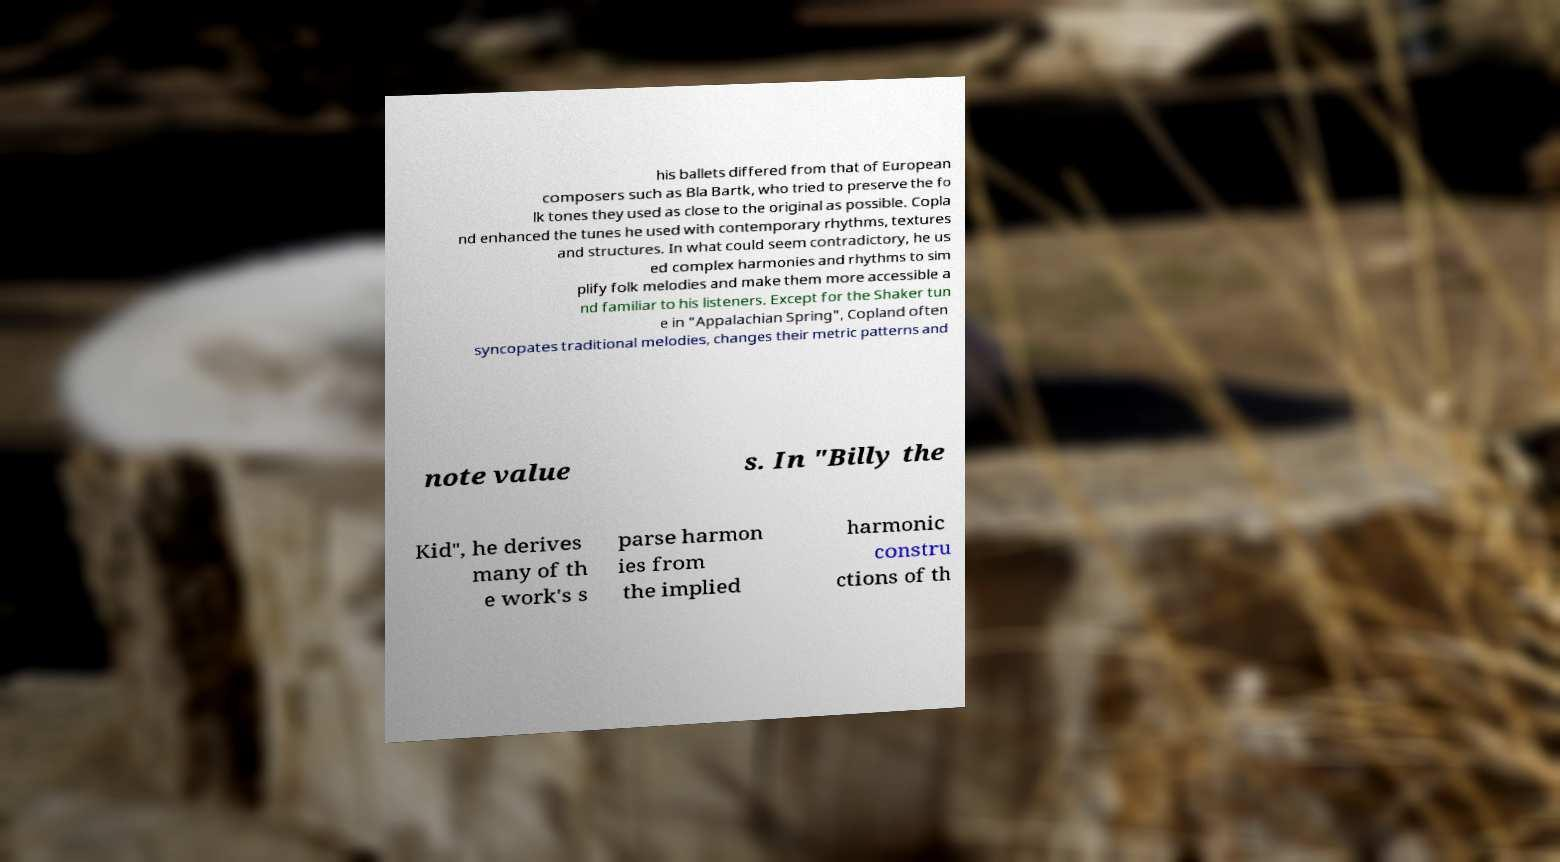Please identify and transcribe the text found in this image. his ballets differed from that of European composers such as Bla Bartk, who tried to preserve the fo lk tones they used as close to the original as possible. Copla nd enhanced the tunes he used with contemporary rhythms, textures and structures. In what could seem contradictory, he us ed complex harmonies and rhythms to sim plify folk melodies and make them more accessible a nd familiar to his listeners. Except for the Shaker tun e in "Appalachian Spring", Copland often syncopates traditional melodies, changes their metric patterns and note value s. In "Billy the Kid", he derives many of th e work's s parse harmon ies from the implied harmonic constru ctions of th 